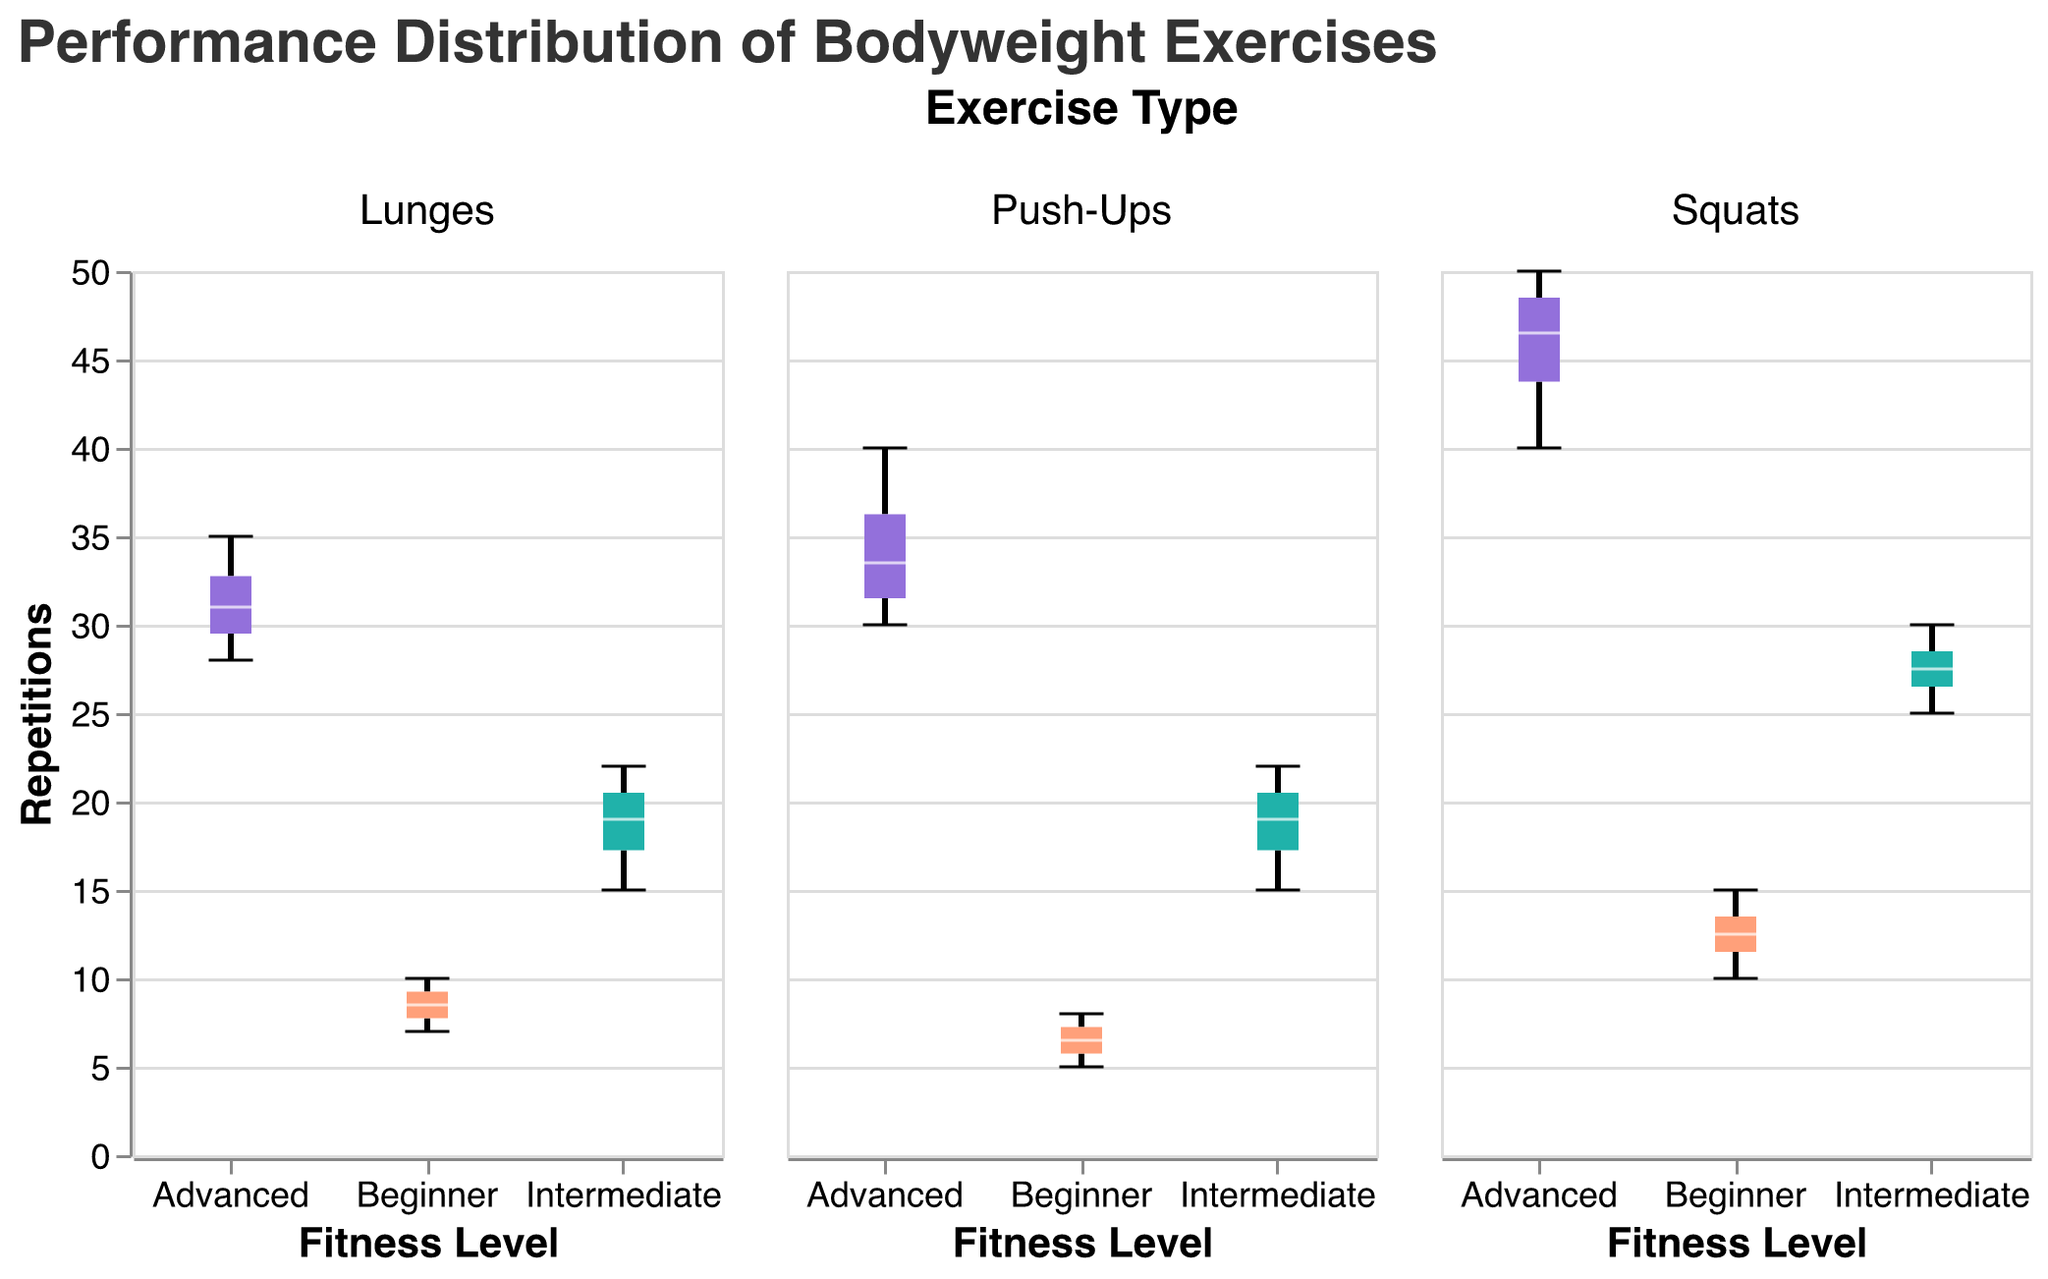What is the overall title of the figure? The title of the figure is typically located at the top and gives a general overview of what the figure is about. In this case, it states "Performance Distribution of Bodyweight Exercises."
Answer: Performance Distribution of Bodyweight Exercises What does the y-axis represent? The y-axis label states what is being measured, in this case, it is "Repetitions." This means the performance in terms of the number of repetitions is plotted along this axis.
Answer: Repetitions Which exercise has the highest maximum performance in the Advanced fitness level? By examining the box plots for the Advanced fitness level across the different exercises, the one with the highest maximum value can be identified. The Squats box plot for Advanced shows the highest repetition of 50.
Answer: Squats What is the median number of push-ups for the Intermediate fitness level? The median value is usually represented by a line inside the box of each box plot. For Intermediate in Push-Ups, the median line is at 18.
Answer: 18 How does the range of squats for the Intermediate level compare to the range for the Beginner level? The range is determined by the minimum and maximum values in each box plot. For Squats, the Intermediate range is from 25 to 30 (a range of 5), whereas the Beginner range is from 10 to 15 (also a range of 5).
Answer: They are the same Which exercise shows the smallest interquartile range (IQR) for the Intermediate level? The IQR is the range between the first and third quartile. By examining each box plot for Intermediate level, Lunges have the smallest IQR.
Answer: Lunges What color represents the Advanced fitness level in the box plots? Each fitness level is represented by a specific color. Advanced is shown with a violet color.
Answer: Violet Between the Advanced levels of Push-Ups and Lunges, which has the higher median performance? The median can be directly read from the box plots. For Advanced, Push-Ups have a median around 32, while Lunges have a median around 30.
Answer: Push-Ups What is the median number of repetitions for Squats at the Beginner level? The median is represented by the line inside the box plot. For Squats at the Beginner level, the median is at 12.
Answer: 12 Which fitness level exhibits the greatest variability in performance for Push-Ups? Variability is typically assessed by the range and IQR. Looking at the Push-Ups box plots, Advanced shows the greatest variability with a range from 30 to 40.
Answer: Advanced 